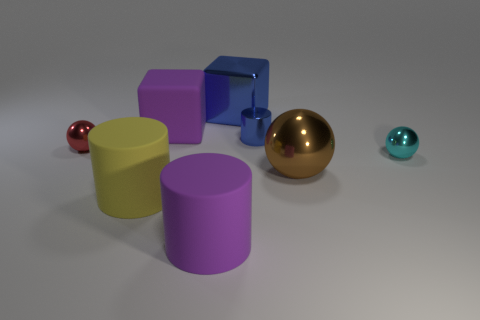What size is the block in front of the metal thing that is behind the small blue thing?
Your response must be concise. Large. Is the number of small metal cylinders to the left of the yellow object less than the number of tiny red shiny things?
Offer a very short reply. Yes. Does the small cylinder have the same color as the metallic cube?
Offer a terse response. Yes. The brown metallic ball has what size?
Provide a succinct answer. Large. What number of large metallic spheres are the same color as the large shiny cube?
Provide a succinct answer. 0. There is a small sphere that is in front of the tiny sphere that is behind the cyan sphere; is there a big blue thing that is left of it?
Offer a very short reply. Yes. The red shiny object that is the same size as the blue metallic cylinder is what shape?
Make the answer very short. Sphere. How many big things are either metal things or brown shiny spheres?
Offer a very short reply. 2. The big ball that is made of the same material as the tiny cylinder is what color?
Your answer should be compact. Brown. Do the purple object that is in front of the brown ball and the big metal thing that is left of the small blue thing have the same shape?
Offer a very short reply. No. 